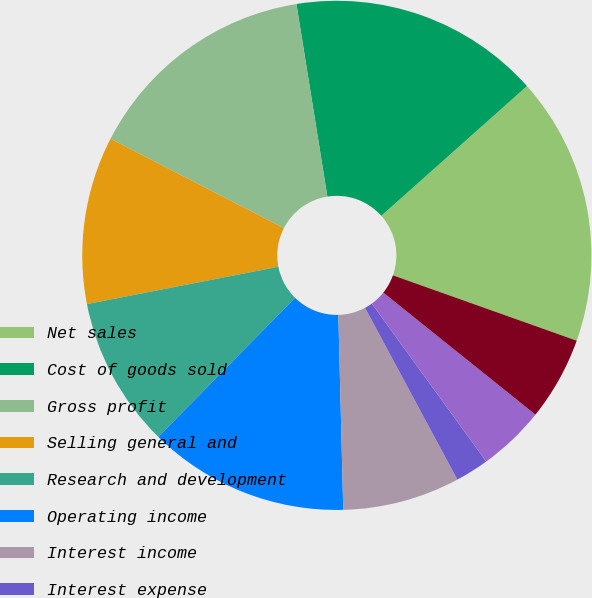<chart> <loc_0><loc_0><loc_500><loc_500><pie_chart><fcel>Net sales<fcel>Cost of goods sold<fcel>Gross profit<fcel>Selling general and<fcel>Research and development<fcel>Operating income<fcel>Interest income<fcel>Interest expense<fcel>Foreign currency<fcel>Gain on sale of equity<nl><fcel>17.02%<fcel>15.96%<fcel>14.89%<fcel>10.64%<fcel>9.57%<fcel>12.77%<fcel>7.45%<fcel>2.13%<fcel>4.26%<fcel>5.32%<nl></chart> 